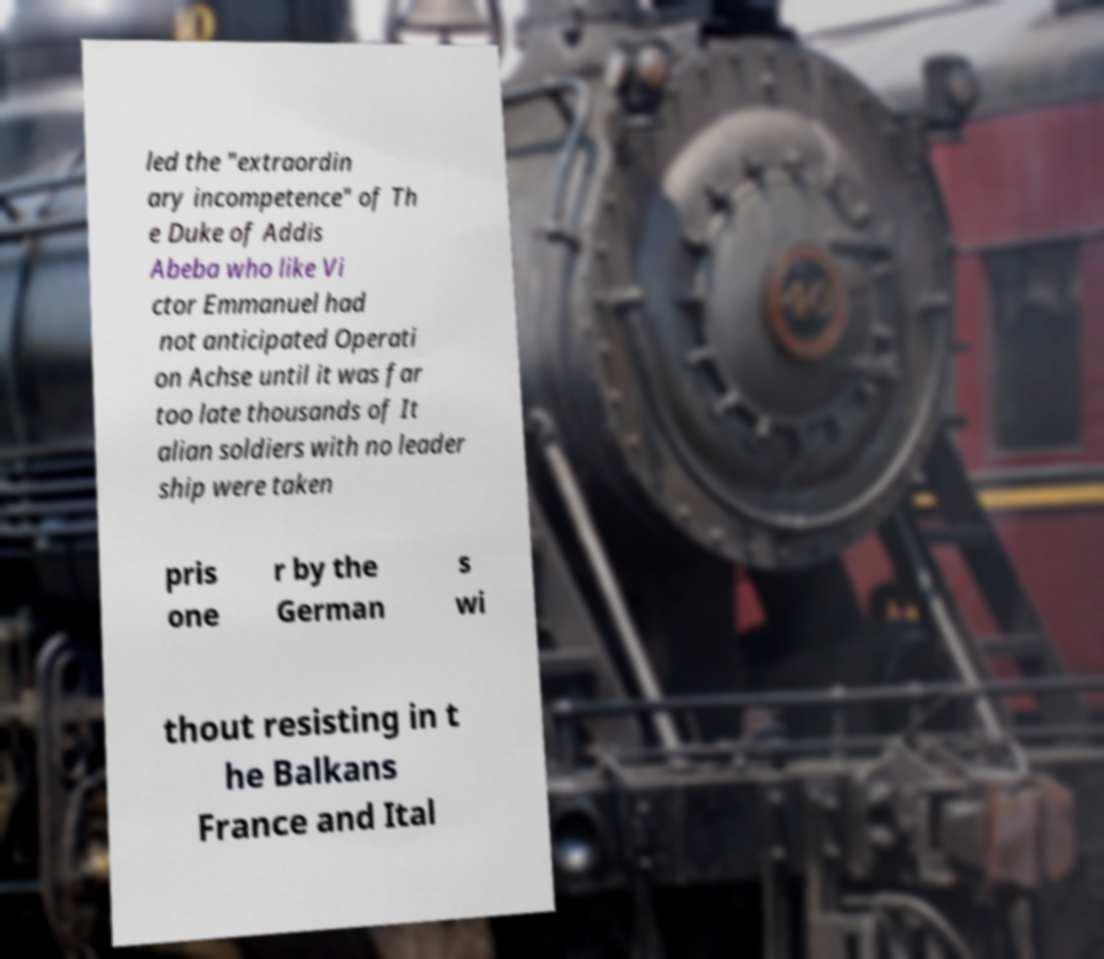For documentation purposes, I need the text within this image transcribed. Could you provide that? led the "extraordin ary incompetence" of Th e Duke of Addis Abeba who like Vi ctor Emmanuel had not anticipated Operati on Achse until it was far too late thousands of It alian soldiers with no leader ship were taken pris one r by the German s wi thout resisting in t he Balkans France and Ital 